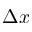Convert formula to latex. <formula><loc_0><loc_0><loc_500><loc_500>\Delta x</formula> 